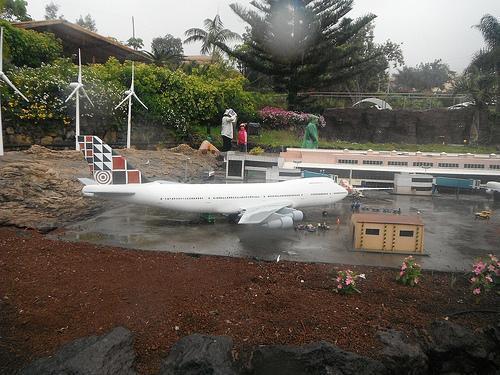How many model airplanes are there?
Give a very brief answer. 1. 